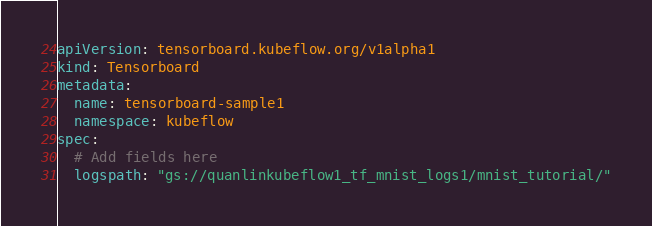<code> <loc_0><loc_0><loc_500><loc_500><_YAML_>apiVersion: tensorboard.kubeflow.org/v1alpha1
kind: Tensorboard
metadata:
  name: tensorboard-sample1
  namespace: kubeflow
spec:
  # Add fields here
  logspath: "gs://quanlinkubeflow1_tf_mnist_logs1/mnist_tutorial/"
</code> 